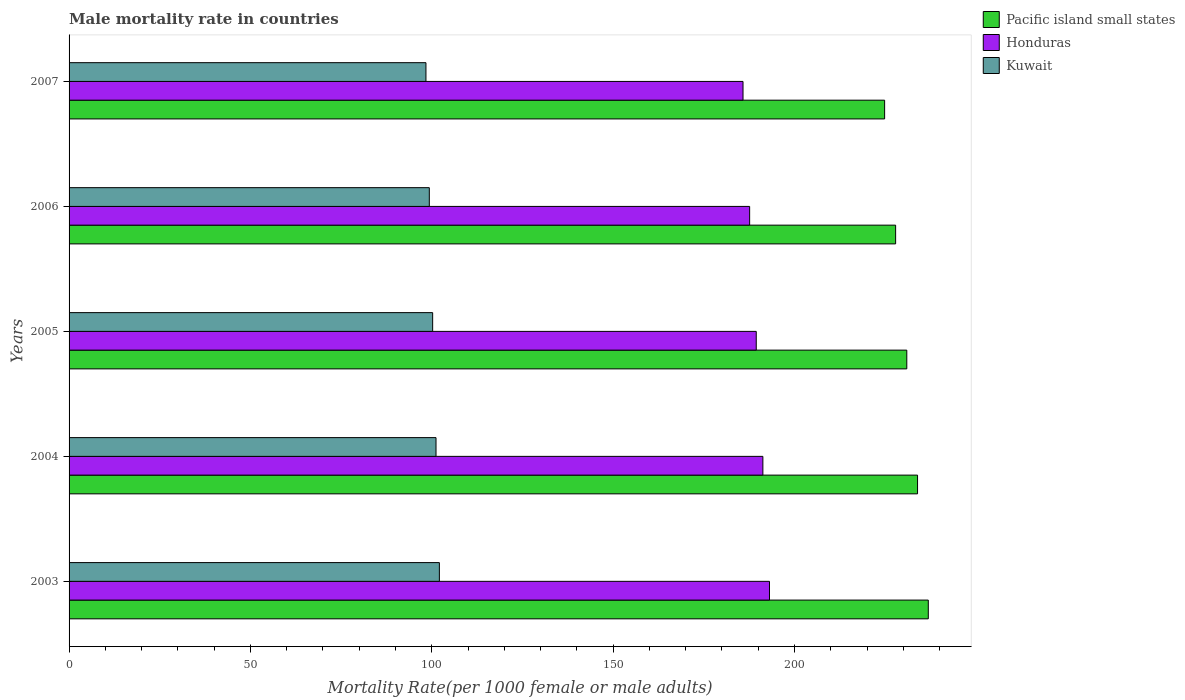How many groups of bars are there?
Make the answer very short. 5. In how many cases, is the number of bars for a given year not equal to the number of legend labels?
Your answer should be very brief. 0. What is the male mortality rate in Honduras in 2005?
Ensure brevity in your answer.  189.46. Across all years, what is the maximum male mortality rate in Kuwait?
Give a very brief answer. 102.1. Across all years, what is the minimum male mortality rate in Kuwait?
Ensure brevity in your answer.  98.39. In which year was the male mortality rate in Kuwait maximum?
Make the answer very short. 2003. In which year was the male mortality rate in Pacific island small states minimum?
Offer a very short reply. 2007. What is the total male mortality rate in Pacific island small states in the graph?
Offer a very short reply. 1154.53. What is the difference between the male mortality rate in Kuwait in 2003 and that in 2005?
Make the answer very short. 1.85. What is the difference between the male mortality rate in Kuwait in 2006 and the male mortality rate in Honduras in 2007?
Ensure brevity in your answer.  -86.49. What is the average male mortality rate in Honduras per year?
Keep it short and to the point. 189.46. In the year 2003, what is the difference between the male mortality rate in Pacific island small states and male mortality rate in Kuwait?
Ensure brevity in your answer.  134.8. In how many years, is the male mortality rate in Pacific island small states greater than 80 ?
Provide a short and direct response. 5. What is the ratio of the male mortality rate in Honduras in 2003 to that in 2004?
Provide a short and direct response. 1.01. Is the male mortality rate in Kuwait in 2005 less than that in 2007?
Offer a very short reply. No. Is the difference between the male mortality rate in Pacific island small states in 2005 and 2006 greater than the difference between the male mortality rate in Kuwait in 2005 and 2006?
Keep it short and to the point. Yes. What is the difference between the highest and the second highest male mortality rate in Pacific island small states?
Offer a terse response. 2.96. What is the difference between the highest and the lowest male mortality rate in Pacific island small states?
Give a very brief answer. 12.04. In how many years, is the male mortality rate in Honduras greater than the average male mortality rate in Honduras taken over all years?
Make the answer very short. 2. Is the sum of the male mortality rate in Honduras in 2004 and 2006 greater than the maximum male mortality rate in Pacific island small states across all years?
Provide a short and direct response. Yes. What does the 2nd bar from the top in 2003 represents?
Provide a succinct answer. Honduras. What does the 3rd bar from the bottom in 2003 represents?
Your response must be concise. Kuwait. Is it the case that in every year, the sum of the male mortality rate in Kuwait and male mortality rate in Honduras is greater than the male mortality rate in Pacific island small states?
Your response must be concise. Yes. How many bars are there?
Ensure brevity in your answer.  15. What is the difference between two consecutive major ticks on the X-axis?
Keep it short and to the point. 50. Does the graph contain any zero values?
Your answer should be compact. No. Does the graph contain grids?
Provide a succinct answer. No. Where does the legend appear in the graph?
Keep it short and to the point. Top right. How many legend labels are there?
Offer a very short reply. 3. What is the title of the graph?
Make the answer very short. Male mortality rate in countries. What is the label or title of the X-axis?
Offer a very short reply. Mortality Rate(per 1000 female or male adults). What is the label or title of the Y-axis?
Offer a very short reply. Years. What is the Mortality Rate(per 1000 female or male adults) of Pacific island small states in 2003?
Your answer should be very brief. 236.9. What is the Mortality Rate(per 1000 female or male adults) of Honduras in 2003?
Give a very brief answer. 193.11. What is the Mortality Rate(per 1000 female or male adults) in Kuwait in 2003?
Make the answer very short. 102.1. What is the Mortality Rate(per 1000 female or male adults) of Pacific island small states in 2004?
Provide a succinct answer. 233.93. What is the Mortality Rate(per 1000 female or male adults) of Honduras in 2004?
Make the answer very short. 191.29. What is the Mortality Rate(per 1000 female or male adults) of Kuwait in 2004?
Your answer should be very brief. 101.17. What is the Mortality Rate(per 1000 female or male adults) of Pacific island small states in 2005?
Provide a succinct answer. 230.97. What is the Mortality Rate(per 1000 female or male adults) of Honduras in 2005?
Provide a succinct answer. 189.46. What is the Mortality Rate(per 1000 female or male adults) of Kuwait in 2005?
Keep it short and to the point. 100.25. What is the Mortality Rate(per 1000 female or male adults) in Pacific island small states in 2006?
Keep it short and to the point. 227.89. What is the Mortality Rate(per 1000 female or male adults) in Honduras in 2006?
Your answer should be compact. 187.64. What is the Mortality Rate(per 1000 female or male adults) of Kuwait in 2006?
Ensure brevity in your answer.  99.32. What is the Mortality Rate(per 1000 female or male adults) of Pacific island small states in 2007?
Offer a terse response. 224.85. What is the Mortality Rate(per 1000 female or male adults) of Honduras in 2007?
Your answer should be very brief. 185.81. What is the Mortality Rate(per 1000 female or male adults) of Kuwait in 2007?
Offer a terse response. 98.39. Across all years, what is the maximum Mortality Rate(per 1000 female or male adults) of Pacific island small states?
Make the answer very short. 236.9. Across all years, what is the maximum Mortality Rate(per 1000 female or male adults) of Honduras?
Make the answer very short. 193.11. Across all years, what is the maximum Mortality Rate(per 1000 female or male adults) in Kuwait?
Your response must be concise. 102.1. Across all years, what is the minimum Mortality Rate(per 1000 female or male adults) of Pacific island small states?
Keep it short and to the point. 224.85. Across all years, what is the minimum Mortality Rate(per 1000 female or male adults) of Honduras?
Ensure brevity in your answer.  185.81. Across all years, what is the minimum Mortality Rate(per 1000 female or male adults) of Kuwait?
Offer a very short reply. 98.39. What is the total Mortality Rate(per 1000 female or male adults) of Pacific island small states in the graph?
Make the answer very short. 1154.53. What is the total Mortality Rate(per 1000 female or male adults) of Honduras in the graph?
Provide a short and direct response. 947.31. What is the total Mortality Rate(per 1000 female or male adults) in Kuwait in the graph?
Your response must be concise. 501.23. What is the difference between the Mortality Rate(per 1000 female or male adults) in Pacific island small states in 2003 and that in 2004?
Ensure brevity in your answer.  2.96. What is the difference between the Mortality Rate(per 1000 female or male adults) in Honduras in 2003 and that in 2004?
Provide a short and direct response. 1.82. What is the difference between the Mortality Rate(per 1000 female or male adults) in Kuwait in 2003 and that in 2004?
Provide a short and direct response. 0.93. What is the difference between the Mortality Rate(per 1000 female or male adults) of Pacific island small states in 2003 and that in 2005?
Make the answer very short. 5.93. What is the difference between the Mortality Rate(per 1000 female or male adults) in Honduras in 2003 and that in 2005?
Make the answer very short. 3.65. What is the difference between the Mortality Rate(per 1000 female or male adults) of Kuwait in 2003 and that in 2005?
Provide a succinct answer. 1.85. What is the difference between the Mortality Rate(per 1000 female or male adults) in Pacific island small states in 2003 and that in 2006?
Your response must be concise. 9.01. What is the difference between the Mortality Rate(per 1000 female or male adults) of Honduras in 2003 and that in 2006?
Make the answer very short. 5.47. What is the difference between the Mortality Rate(per 1000 female or male adults) in Kuwait in 2003 and that in 2006?
Provide a succinct answer. 2.78. What is the difference between the Mortality Rate(per 1000 female or male adults) in Pacific island small states in 2003 and that in 2007?
Offer a very short reply. 12.04. What is the difference between the Mortality Rate(per 1000 female or male adults) of Honduras in 2003 and that in 2007?
Ensure brevity in your answer.  7.3. What is the difference between the Mortality Rate(per 1000 female or male adults) of Kuwait in 2003 and that in 2007?
Your answer should be compact. 3.7. What is the difference between the Mortality Rate(per 1000 female or male adults) of Pacific island small states in 2004 and that in 2005?
Your answer should be very brief. 2.96. What is the difference between the Mortality Rate(per 1000 female or male adults) of Honduras in 2004 and that in 2005?
Give a very brief answer. 1.82. What is the difference between the Mortality Rate(per 1000 female or male adults) in Kuwait in 2004 and that in 2005?
Offer a terse response. 0.93. What is the difference between the Mortality Rate(per 1000 female or male adults) of Pacific island small states in 2004 and that in 2006?
Keep it short and to the point. 6.04. What is the difference between the Mortality Rate(per 1000 female or male adults) of Honduras in 2004 and that in 2006?
Offer a very short reply. 3.65. What is the difference between the Mortality Rate(per 1000 female or male adults) of Kuwait in 2004 and that in 2006?
Keep it short and to the point. 1.85. What is the difference between the Mortality Rate(per 1000 female or male adults) in Pacific island small states in 2004 and that in 2007?
Provide a succinct answer. 9.08. What is the difference between the Mortality Rate(per 1000 female or male adults) of Honduras in 2004 and that in 2007?
Your response must be concise. 5.47. What is the difference between the Mortality Rate(per 1000 female or male adults) in Kuwait in 2004 and that in 2007?
Give a very brief answer. 2.78. What is the difference between the Mortality Rate(per 1000 female or male adults) of Pacific island small states in 2005 and that in 2006?
Provide a succinct answer. 3.08. What is the difference between the Mortality Rate(per 1000 female or male adults) in Honduras in 2005 and that in 2006?
Keep it short and to the point. 1.82. What is the difference between the Mortality Rate(per 1000 female or male adults) in Kuwait in 2005 and that in 2006?
Ensure brevity in your answer.  0.93. What is the difference between the Mortality Rate(per 1000 female or male adults) of Pacific island small states in 2005 and that in 2007?
Offer a terse response. 6.11. What is the difference between the Mortality Rate(per 1000 female or male adults) in Honduras in 2005 and that in 2007?
Offer a terse response. 3.65. What is the difference between the Mortality Rate(per 1000 female or male adults) in Kuwait in 2005 and that in 2007?
Make the answer very short. 1.85. What is the difference between the Mortality Rate(per 1000 female or male adults) of Pacific island small states in 2006 and that in 2007?
Give a very brief answer. 3.03. What is the difference between the Mortality Rate(per 1000 female or male adults) of Honduras in 2006 and that in 2007?
Provide a short and direct response. 1.82. What is the difference between the Mortality Rate(per 1000 female or male adults) of Kuwait in 2006 and that in 2007?
Keep it short and to the point. 0.93. What is the difference between the Mortality Rate(per 1000 female or male adults) of Pacific island small states in 2003 and the Mortality Rate(per 1000 female or male adults) of Honduras in 2004?
Your answer should be compact. 45.61. What is the difference between the Mortality Rate(per 1000 female or male adults) of Pacific island small states in 2003 and the Mortality Rate(per 1000 female or male adults) of Kuwait in 2004?
Give a very brief answer. 135.72. What is the difference between the Mortality Rate(per 1000 female or male adults) in Honduras in 2003 and the Mortality Rate(per 1000 female or male adults) in Kuwait in 2004?
Keep it short and to the point. 91.94. What is the difference between the Mortality Rate(per 1000 female or male adults) of Pacific island small states in 2003 and the Mortality Rate(per 1000 female or male adults) of Honduras in 2005?
Give a very brief answer. 47.43. What is the difference between the Mortality Rate(per 1000 female or male adults) of Pacific island small states in 2003 and the Mortality Rate(per 1000 female or male adults) of Kuwait in 2005?
Keep it short and to the point. 136.65. What is the difference between the Mortality Rate(per 1000 female or male adults) of Honduras in 2003 and the Mortality Rate(per 1000 female or male adults) of Kuwait in 2005?
Offer a terse response. 92.87. What is the difference between the Mortality Rate(per 1000 female or male adults) in Pacific island small states in 2003 and the Mortality Rate(per 1000 female or male adults) in Honduras in 2006?
Make the answer very short. 49.26. What is the difference between the Mortality Rate(per 1000 female or male adults) in Pacific island small states in 2003 and the Mortality Rate(per 1000 female or male adults) in Kuwait in 2006?
Keep it short and to the point. 137.58. What is the difference between the Mortality Rate(per 1000 female or male adults) in Honduras in 2003 and the Mortality Rate(per 1000 female or male adults) in Kuwait in 2006?
Your answer should be very brief. 93.79. What is the difference between the Mortality Rate(per 1000 female or male adults) in Pacific island small states in 2003 and the Mortality Rate(per 1000 female or male adults) in Honduras in 2007?
Your answer should be compact. 51.08. What is the difference between the Mortality Rate(per 1000 female or male adults) in Pacific island small states in 2003 and the Mortality Rate(per 1000 female or male adults) in Kuwait in 2007?
Your answer should be compact. 138.5. What is the difference between the Mortality Rate(per 1000 female or male adults) of Honduras in 2003 and the Mortality Rate(per 1000 female or male adults) of Kuwait in 2007?
Make the answer very short. 94.72. What is the difference between the Mortality Rate(per 1000 female or male adults) in Pacific island small states in 2004 and the Mortality Rate(per 1000 female or male adults) in Honduras in 2005?
Keep it short and to the point. 44.47. What is the difference between the Mortality Rate(per 1000 female or male adults) in Pacific island small states in 2004 and the Mortality Rate(per 1000 female or male adults) in Kuwait in 2005?
Offer a very short reply. 133.69. What is the difference between the Mortality Rate(per 1000 female or male adults) in Honduras in 2004 and the Mortality Rate(per 1000 female or male adults) in Kuwait in 2005?
Give a very brief answer. 91.04. What is the difference between the Mortality Rate(per 1000 female or male adults) in Pacific island small states in 2004 and the Mortality Rate(per 1000 female or male adults) in Honduras in 2006?
Give a very brief answer. 46.29. What is the difference between the Mortality Rate(per 1000 female or male adults) in Pacific island small states in 2004 and the Mortality Rate(per 1000 female or male adults) in Kuwait in 2006?
Offer a very short reply. 134.61. What is the difference between the Mortality Rate(per 1000 female or male adults) of Honduras in 2004 and the Mortality Rate(per 1000 female or male adults) of Kuwait in 2006?
Offer a terse response. 91.97. What is the difference between the Mortality Rate(per 1000 female or male adults) in Pacific island small states in 2004 and the Mortality Rate(per 1000 female or male adults) in Honduras in 2007?
Keep it short and to the point. 48.12. What is the difference between the Mortality Rate(per 1000 female or male adults) of Pacific island small states in 2004 and the Mortality Rate(per 1000 female or male adults) of Kuwait in 2007?
Your response must be concise. 135.54. What is the difference between the Mortality Rate(per 1000 female or male adults) of Honduras in 2004 and the Mortality Rate(per 1000 female or male adults) of Kuwait in 2007?
Give a very brief answer. 92.89. What is the difference between the Mortality Rate(per 1000 female or male adults) in Pacific island small states in 2005 and the Mortality Rate(per 1000 female or male adults) in Honduras in 2006?
Your answer should be very brief. 43.33. What is the difference between the Mortality Rate(per 1000 female or male adults) of Pacific island small states in 2005 and the Mortality Rate(per 1000 female or male adults) of Kuwait in 2006?
Ensure brevity in your answer.  131.65. What is the difference between the Mortality Rate(per 1000 female or male adults) in Honduras in 2005 and the Mortality Rate(per 1000 female or male adults) in Kuwait in 2006?
Provide a short and direct response. 90.14. What is the difference between the Mortality Rate(per 1000 female or male adults) in Pacific island small states in 2005 and the Mortality Rate(per 1000 female or male adults) in Honduras in 2007?
Provide a succinct answer. 45.15. What is the difference between the Mortality Rate(per 1000 female or male adults) of Pacific island small states in 2005 and the Mortality Rate(per 1000 female or male adults) of Kuwait in 2007?
Your response must be concise. 132.57. What is the difference between the Mortality Rate(per 1000 female or male adults) in Honduras in 2005 and the Mortality Rate(per 1000 female or male adults) in Kuwait in 2007?
Provide a short and direct response. 91.07. What is the difference between the Mortality Rate(per 1000 female or male adults) in Pacific island small states in 2006 and the Mortality Rate(per 1000 female or male adults) in Honduras in 2007?
Your answer should be compact. 42.07. What is the difference between the Mortality Rate(per 1000 female or male adults) in Pacific island small states in 2006 and the Mortality Rate(per 1000 female or male adults) in Kuwait in 2007?
Offer a terse response. 129.49. What is the difference between the Mortality Rate(per 1000 female or male adults) of Honduras in 2006 and the Mortality Rate(per 1000 female or male adults) of Kuwait in 2007?
Keep it short and to the point. 89.24. What is the average Mortality Rate(per 1000 female or male adults) in Pacific island small states per year?
Ensure brevity in your answer.  230.91. What is the average Mortality Rate(per 1000 female or male adults) in Honduras per year?
Offer a terse response. 189.46. What is the average Mortality Rate(per 1000 female or male adults) of Kuwait per year?
Your answer should be very brief. 100.25. In the year 2003, what is the difference between the Mortality Rate(per 1000 female or male adults) of Pacific island small states and Mortality Rate(per 1000 female or male adults) of Honduras?
Offer a terse response. 43.78. In the year 2003, what is the difference between the Mortality Rate(per 1000 female or male adults) in Pacific island small states and Mortality Rate(per 1000 female or male adults) in Kuwait?
Your answer should be very brief. 134.8. In the year 2003, what is the difference between the Mortality Rate(per 1000 female or male adults) in Honduras and Mortality Rate(per 1000 female or male adults) in Kuwait?
Offer a very short reply. 91.01. In the year 2004, what is the difference between the Mortality Rate(per 1000 female or male adults) in Pacific island small states and Mortality Rate(per 1000 female or male adults) in Honduras?
Offer a very short reply. 42.64. In the year 2004, what is the difference between the Mortality Rate(per 1000 female or male adults) in Pacific island small states and Mortality Rate(per 1000 female or male adults) in Kuwait?
Offer a terse response. 132.76. In the year 2004, what is the difference between the Mortality Rate(per 1000 female or male adults) in Honduras and Mortality Rate(per 1000 female or male adults) in Kuwait?
Keep it short and to the point. 90.12. In the year 2005, what is the difference between the Mortality Rate(per 1000 female or male adults) in Pacific island small states and Mortality Rate(per 1000 female or male adults) in Honduras?
Offer a terse response. 41.51. In the year 2005, what is the difference between the Mortality Rate(per 1000 female or male adults) of Pacific island small states and Mortality Rate(per 1000 female or male adults) of Kuwait?
Your response must be concise. 130.72. In the year 2005, what is the difference between the Mortality Rate(per 1000 female or male adults) in Honduras and Mortality Rate(per 1000 female or male adults) in Kuwait?
Offer a very short reply. 89.22. In the year 2006, what is the difference between the Mortality Rate(per 1000 female or male adults) of Pacific island small states and Mortality Rate(per 1000 female or male adults) of Honduras?
Your response must be concise. 40.25. In the year 2006, what is the difference between the Mortality Rate(per 1000 female or male adults) of Pacific island small states and Mortality Rate(per 1000 female or male adults) of Kuwait?
Ensure brevity in your answer.  128.57. In the year 2006, what is the difference between the Mortality Rate(per 1000 female or male adults) in Honduras and Mortality Rate(per 1000 female or male adults) in Kuwait?
Provide a succinct answer. 88.32. In the year 2007, what is the difference between the Mortality Rate(per 1000 female or male adults) in Pacific island small states and Mortality Rate(per 1000 female or male adults) in Honduras?
Ensure brevity in your answer.  39.04. In the year 2007, what is the difference between the Mortality Rate(per 1000 female or male adults) of Pacific island small states and Mortality Rate(per 1000 female or male adults) of Kuwait?
Your response must be concise. 126.46. In the year 2007, what is the difference between the Mortality Rate(per 1000 female or male adults) in Honduras and Mortality Rate(per 1000 female or male adults) in Kuwait?
Provide a short and direct response. 87.42. What is the ratio of the Mortality Rate(per 1000 female or male adults) of Pacific island small states in 2003 to that in 2004?
Offer a terse response. 1.01. What is the ratio of the Mortality Rate(per 1000 female or male adults) of Honduras in 2003 to that in 2004?
Your answer should be very brief. 1.01. What is the ratio of the Mortality Rate(per 1000 female or male adults) of Kuwait in 2003 to that in 2004?
Offer a very short reply. 1.01. What is the ratio of the Mortality Rate(per 1000 female or male adults) of Pacific island small states in 2003 to that in 2005?
Offer a very short reply. 1.03. What is the ratio of the Mortality Rate(per 1000 female or male adults) of Honduras in 2003 to that in 2005?
Offer a very short reply. 1.02. What is the ratio of the Mortality Rate(per 1000 female or male adults) in Kuwait in 2003 to that in 2005?
Offer a terse response. 1.02. What is the ratio of the Mortality Rate(per 1000 female or male adults) in Pacific island small states in 2003 to that in 2006?
Offer a terse response. 1.04. What is the ratio of the Mortality Rate(per 1000 female or male adults) in Honduras in 2003 to that in 2006?
Ensure brevity in your answer.  1.03. What is the ratio of the Mortality Rate(per 1000 female or male adults) of Kuwait in 2003 to that in 2006?
Provide a succinct answer. 1.03. What is the ratio of the Mortality Rate(per 1000 female or male adults) in Pacific island small states in 2003 to that in 2007?
Offer a terse response. 1.05. What is the ratio of the Mortality Rate(per 1000 female or male adults) in Honduras in 2003 to that in 2007?
Give a very brief answer. 1.04. What is the ratio of the Mortality Rate(per 1000 female or male adults) of Kuwait in 2003 to that in 2007?
Keep it short and to the point. 1.04. What is the ratio of the Mortality Rate(per 1000 female or male adults) of Pacific island small states in 2004 to that in 2005?
Offer a very short reply. 1.01. What is the ratio of the Mortality Rate(per 1000 female or male adults) in Honduras in 2004 to that in 2005?
Make the answer very short. 1.01. What is the ratio of the Mortality Rate(per 1000 female or male adults) of Kuwait in 2004 to that in 2005?
Provide a succinct answer. 1.01. What is the ratio of the Mortality Rate(per 1000 female or male adults) in Pacific island small states in 2004 to that in 2006?
Provide a short and direct response. 1.03. What is the ratio of the Mortality Rate(per 1000 female or male adults) in Honduras in 2004 to that in 2006?
Offer a very short reply. 1.02. What is the ratio of the Mortality Rate(per 1000 female or male adults) of Kuwait in 2004 to that in 2006?
Ensure brevity in your answer.  1.02. What is the ratio of the Mortality Rate(per 1000 female or male adults) in Pacific island small states in 2004 to that in 2007?
Provide a short and direct response. 1.04. What is the ratio of the Mortality Rate(per 1000 female or male adults) in Honduras in 2004 to that in 2007?
Provide a short and direct response. 1.03. What is the ratio of the Mortality Rate(per 1000 female or male adults) of Kuwait in 2004 to that in 2007?
Provide a succinct answer. 1.03. What is the ratio of the Mortality Rate(per 1000 female or male adults) in Pacific island small states in 2005 to that in 2006?
Provide a short and direct response. 1.01. What is the ratio of the Mortality Rate(per 1000 female or male adults) of Honduras in 2005 to that in 2006?
Provide a succinct answer. 1.01. What is the ratio of the Mortality Rate(per 1000 female or male adults) of Kuwait in 2005 to that in 2006?
Provide a succinct answer. 1.01. What is the ratio of the Mortality Rate(per 1000 female or male adults) in Pacific island small states in 2005 to that in 2007?
Give a very brief answer. 1.03. What is the ratio of the Mortality Rate(per 1000 female or male adults) of Honduras in 2005 to that in 2007?
Provide a succinct answer. 1.02. What is the ratio of the Mortality Rate(per 1000 female or male adults) of Kuwait in 2005 to that in 2007?
Your answer should be compact. 1.02. What is the ratio of the Mortality Rate(per 1000 female or male adults) of Pacific island small states in 2006 to that in 2007?
Ensure brevity in your answer.  1.01. What is the ratio of the Mortality Rate(per 1000 female or male adults) in Honduras in 2006 to that in 2007?
Your answer should be very brief. 1.01. What is the ratio of the Mortality Rate(per 1000 female or male adults) in Kuwait in 2006 to that in 2007?
Keep it short and to the point. 1.01. What is the difference between the highest and the second highest Mortality Rate(per 1000 female or male adults) of Pacific island small states?
Provide a succinct answer. 2.96. What is the difference between the highest and the second highest Mortality Rate(per 1000 female or male adults) in Honduras?
Your answer should be very brief. 1.82. What is the difference between the highest and the second highest Mortality Rate(per 1000 female or male adults) in Kuwait?
Give a very brief answer. 0.93. What is the difference between the highest and the lowest Mortality Rate(per 1000 female or male adults) in Pacific island small states?
Ensure brevity in your answer.  12.04. What is the difference between the highest and the lowest Mortality Rate(per 1000 female or male adults) in Honduras?
Give a very brief answer. 7.3. What is the difference between the highest and the lowest Mortality Rate(per 1000 female or male adults) of Kuwait?
Your answer should be compact. 3.7. 